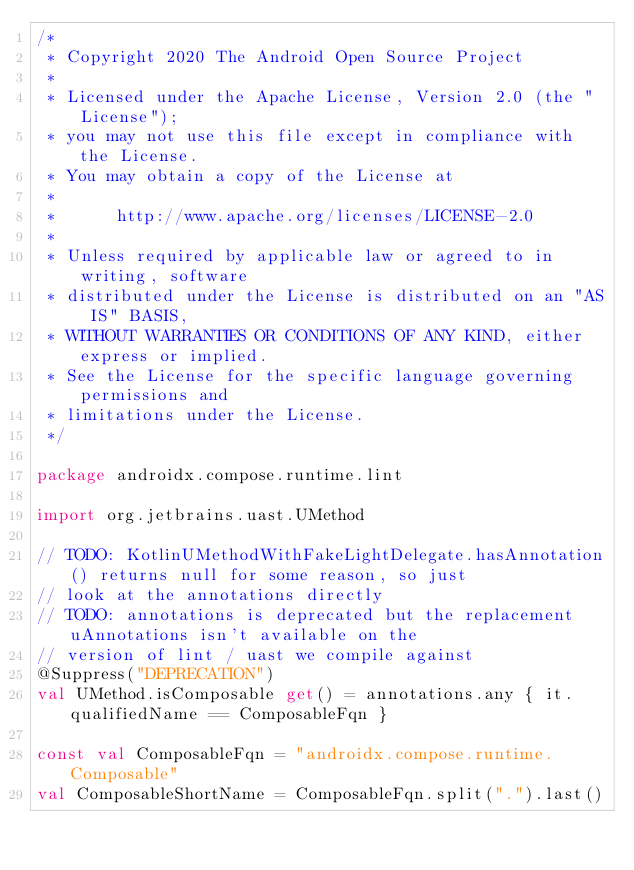<code> <loc_0><loc_0><loc_500><loc_500><_Kotlin_>/*
 * Copyright 2020 The Android Open Source Project
 *
 * Licensed under the Apache License, Version 2.0 (the "License");
 * you may not use this file except in compliance with the License.
 * You may obtain a copy of the License at
 *
 *      http://www.apache.org/licenses/LICENSE-2.0
 *
 * Unless required by applicable law or agreed to in writing, software
 * distributed under the License is distributed on an "AS IS" BASIS,
 * WITHOUT WARRANTIES OR CONDITIONS OF ANY KIND, either express or implied.
 * See the License for the specific language governing permissions and
 * limitations under the License.
 */

package androidx.compose.runtime.lint

import org.jetbrains.uast.UMethod

// TODO: KotlinUMethodWithFakeLightDelegate.hasAnnotation() returns null for some reason, so just
// look at the annotations directly
// TODO: annotations is deprecated but the replacement uAnnotations isn't available on the
// version of lint / uast we compile against
@Suppress("DEPRECATION")
val UMethod.isComposable get() = annotations.any { it.qualifiedName == ComposableFqn }

const val ComposableFqn = "androidx.compose.runtime.Composable"
val ComposableShortName = ComposableFqn.split(".").last()</code> 